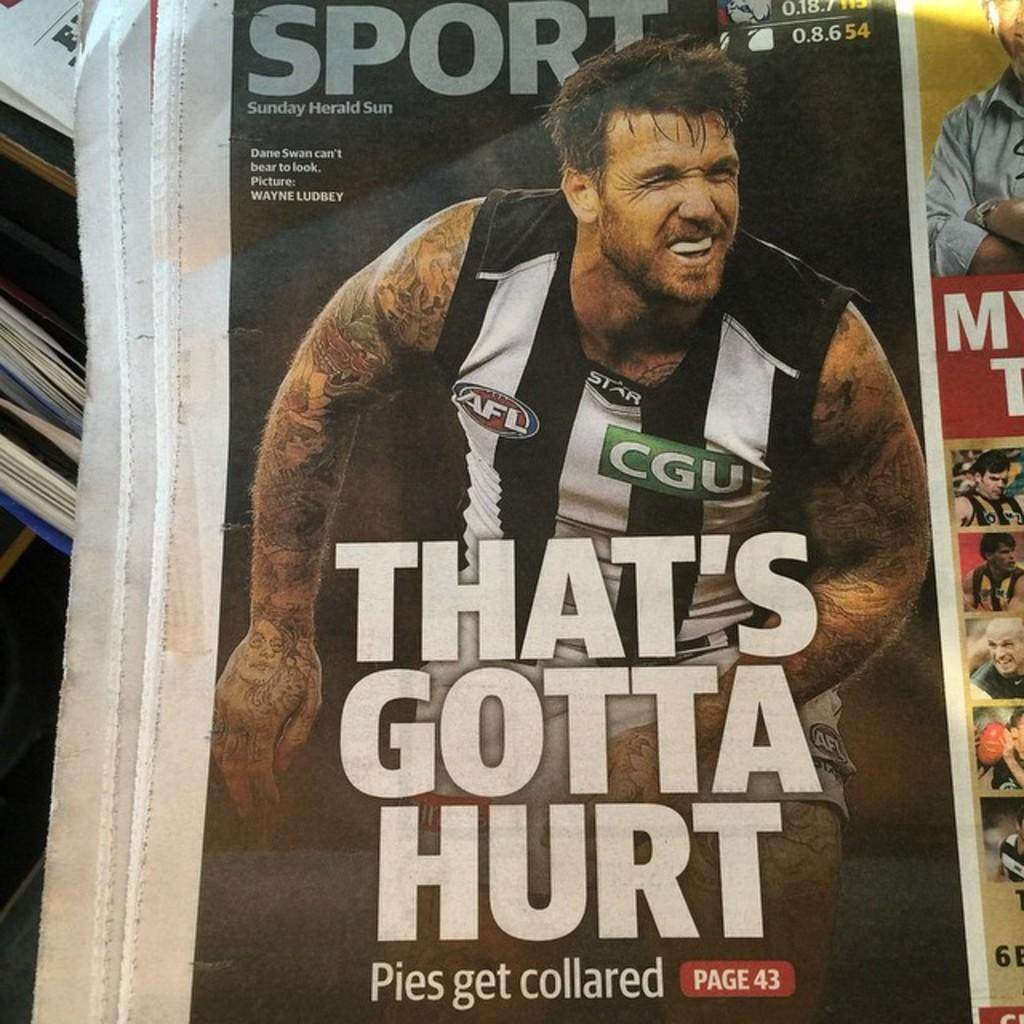What is the main subject of the image? The main subject of the image is a group of people. What can be seen in the image besides the group of people? There is a newspaper with text and books and papers on the left side of the image. How many girls are present at the party in the image? There is no party or girl present in the image; it features a group of people, a newspaper, and books and papers. 